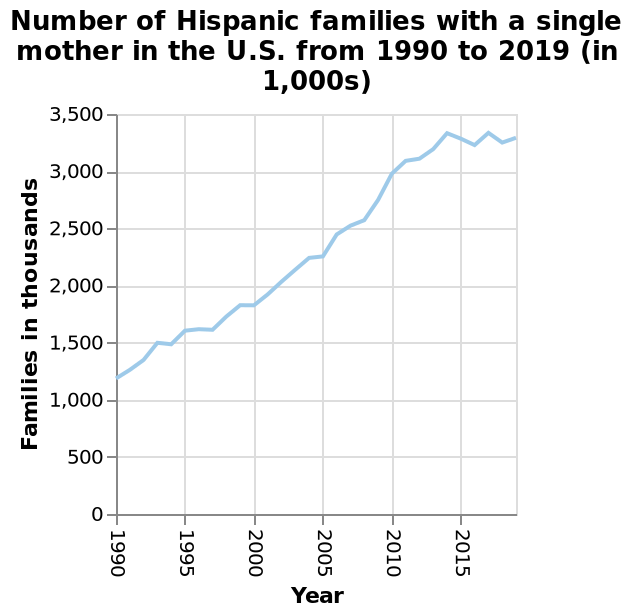<image>
When did the increase in (whatever is being referred to) start? The increase in (whatever is being referred to) started in 1990. When did the increase in (whatever is being referred to) start to level out? The increase in (whatever is being referred to) started to level out from 2014. Is there any noticeable variability in the increase over the years? No, there is no noticeable variability in the increase. It has been steadily increasing until 2014 and remained consistent since then. Did the decrease in (whatever is being referred to) start in 1990? No.The increase in (whatever is being referred to) started in 1990. Did the decrease in (whatever is being referred to) start to level out from 2014? No.The increase in (whatever is being referred to) started to level out from 2014. 